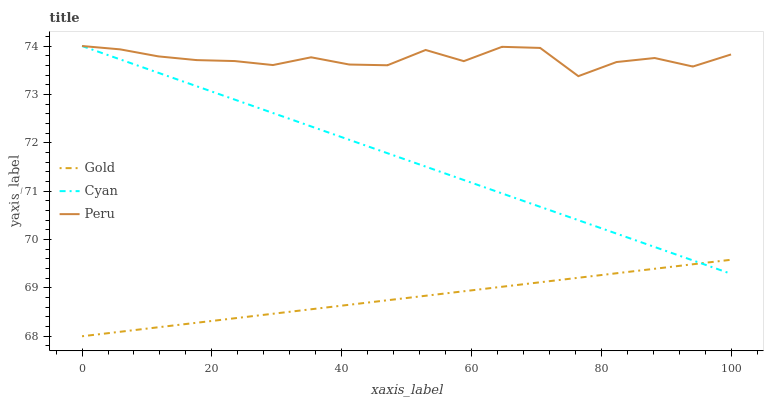Does Gold have the minimum area under the curve?
Answer yes or no. Yes. Does Peru have the maximum area under the curve?
Answer yes or no. Yes. Does Peru have the minimum area under the curve?
Answer yes or no. No. Does Gold have the maximum area under the curve?
Answer yes or no. No. Is Cyan the smoothest?
Answer yes or no. Yes. Is Peru the roughest?
Answer yes or no. Yes. Is Gold the smoothest?
Answer yes or no. No. Is Gold the roughest?
Answer yes or no. No. Does Gold have the lowest value?
Answer yes or no. Yes. Does Peru have the lowest value?
Answer yes or no. No. Does Peru have the highest value?
Answer yes or no. Yes. Does Gold have the highest value?
Answer yes or no. No. Is Gold less than Peru?
Answer yes or no. Yes. Is Peru greater than Gold?
Answer yes or no. Yes. Does Gold intersect Cyan?
Answer yes or no. Yes. Is Gold less than Cyan?
Answer yes or no. No. Is Gold greater than Cyan?
Answer yes or no. No. Does Gold intersect Peru?
Answer yes or no. No. 